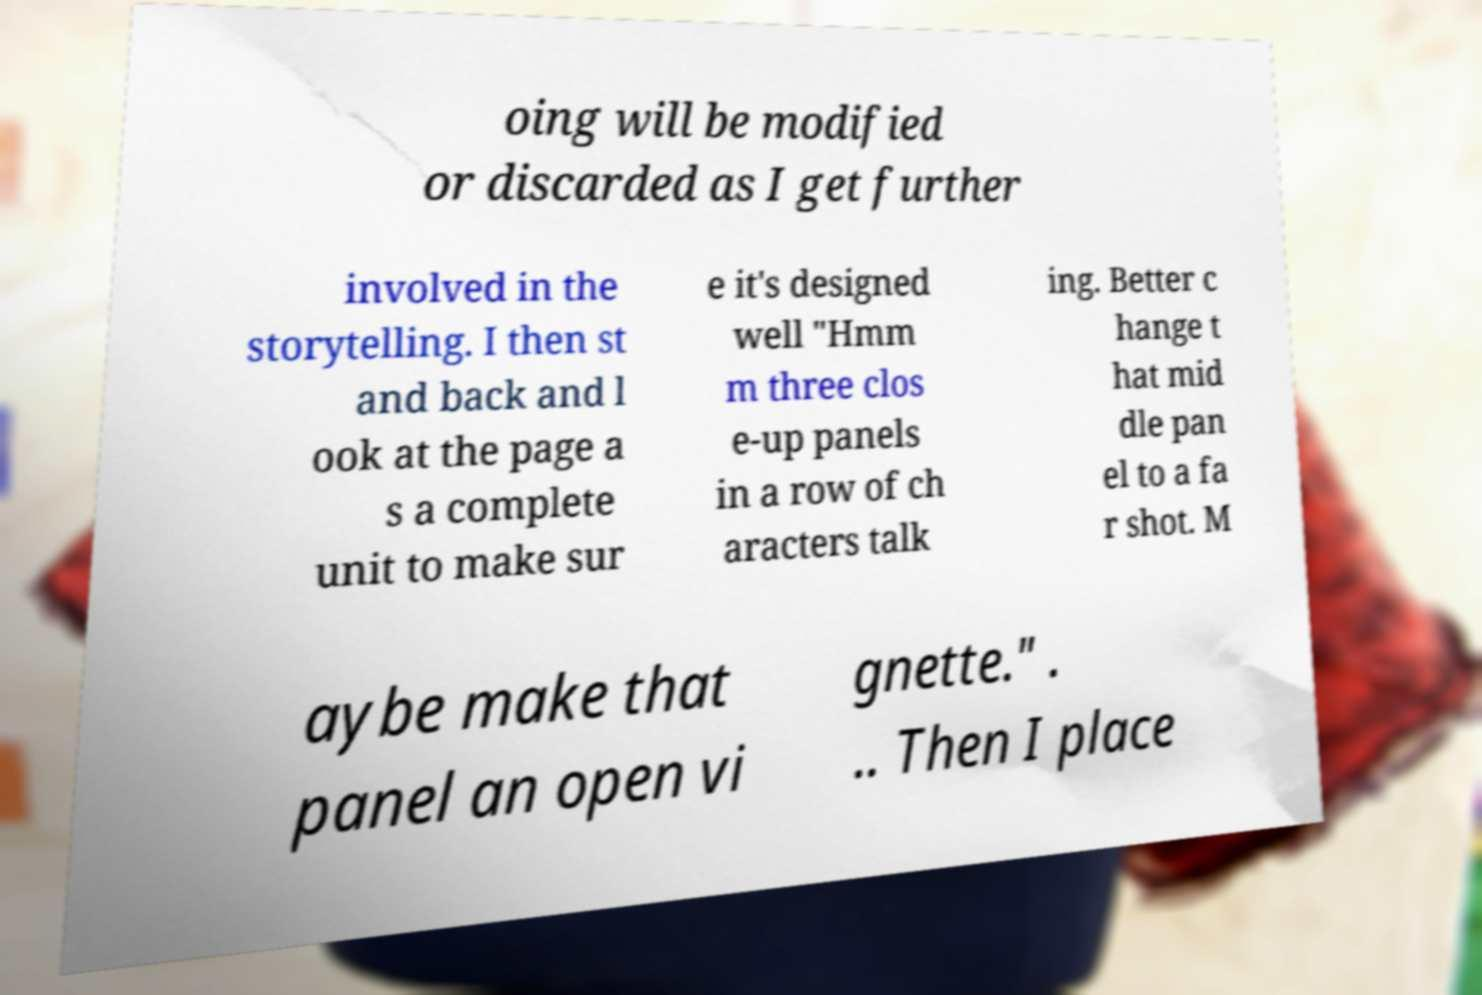Please identify and transcribe the text found in this image. oing will be modified or discarded as I get further involved in the storytelling. I then st and back and l ook at the page a s a complete unit to make sur e it's designed well "Hmm m three clos e-up panels in a row of ch aracters talk ing. Better c hange t hat mid dle pan el to a fa r shot. M aybe make that panel an open vi gnette." . .. Then I place 